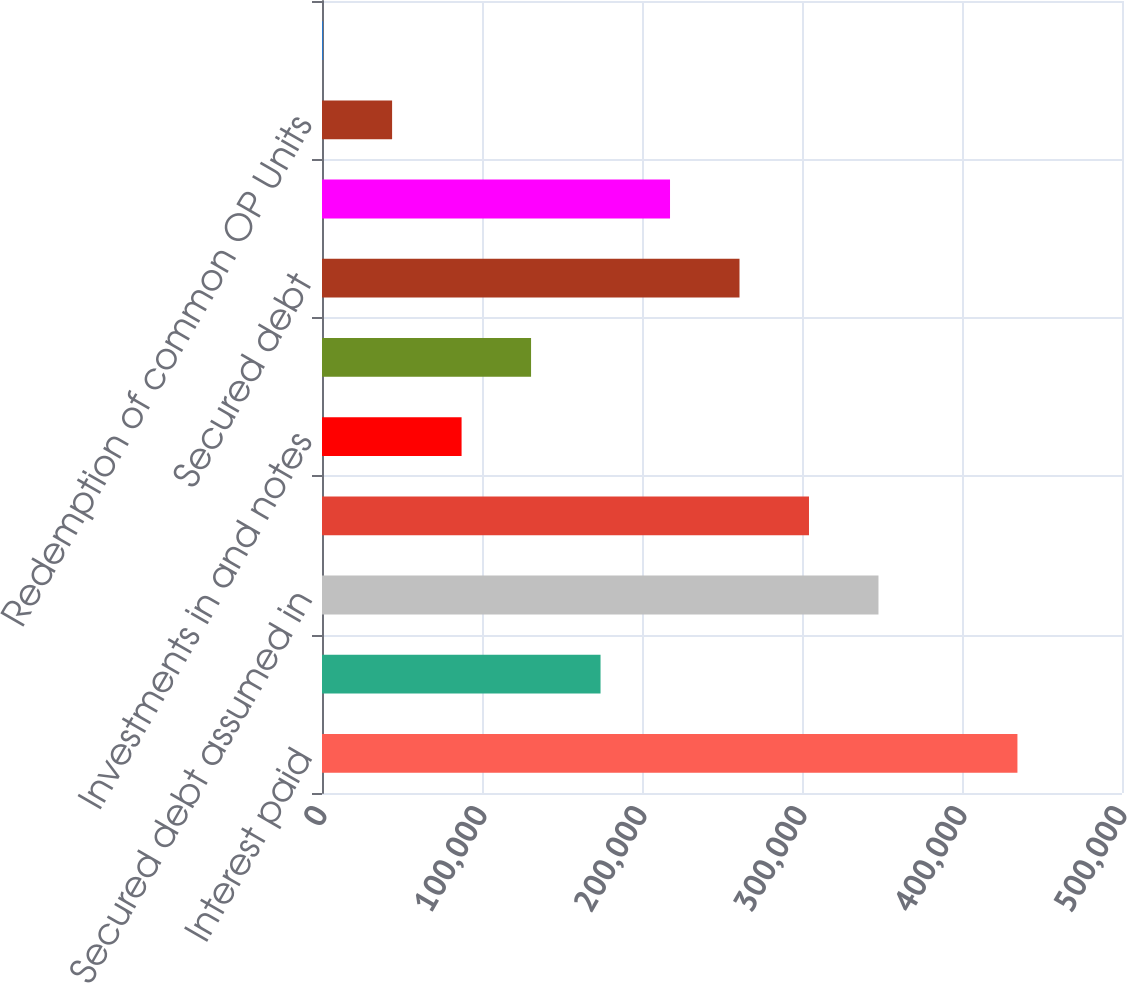Convert chart. <chart><loc_0><loc_0><loc_500><loc_500><bar_chart><fcel>Interest paid<fcel>Cash paid for income taxes<fcel>Secured debt assumed in<fcel>Real estate net<fcel>Investments in and notes<fcel>Restricted cash and other<fcel>Secured debt<fcel>Accounts payable accrued and<fcel>Redemption of common OP Units<fcel>(Cancellation) origination of<nl><fcel>434645<fcel>174089<fcel>347793<fcel>304367<fcel>87237<fcel>130663<fcel>260941<fcel>217515<fcel>43811<fcel>385<nl></chart> 